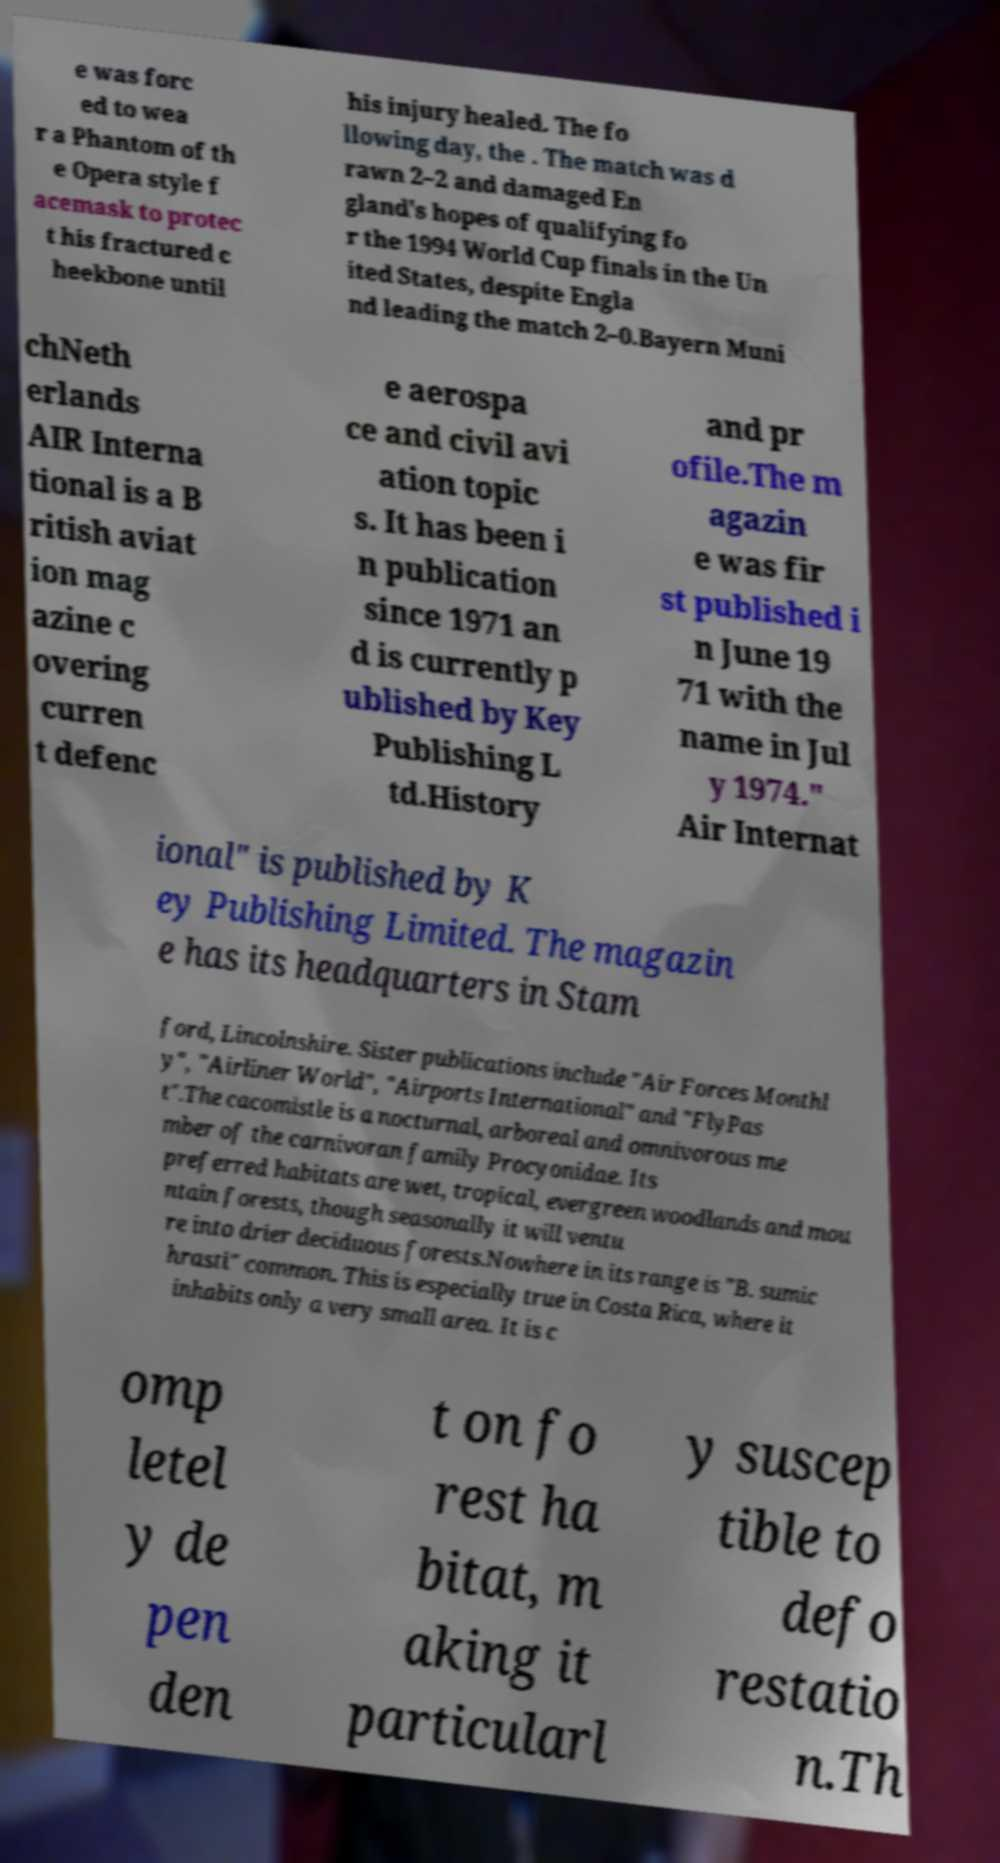For documentation purposes, I need the text within this image transcribed. Could you provide that? e was forc ed to wea r a Phantom of th e Opera style f acemask to protec t his fractured c heekbone until his injury healed. The fo llowing day, the . The match was d rawn 2–2 and damaged En gland's hopes of qualifying fo r the 1994 World Cup finals in the Un ited States, despite Engla nd leading the match 2–0.Bayern Muni chNeth erlands AIR Interna tional is a B ritish aviat ion mag azine c overing curren t defenc e aerospa ce and civil avi ation topic s. It has been i n publication since 1971 an d is currently p ublished by Key Publishing L td.History and pr ofile.The m agazin e was fir st published i n June 19 71 with the name in Jul y 1974." Air Internat ional" is published by K ey Publishing Limited. The magazin e has its headquarters in Stam ford, Lincolnshire. Sister publications include "Air Forces Monthl y", "Airliner World", "Airports International" and "FlyPas t".The cacomistle is a nocturnal, arboreal and omnivorous me mber of the carnivoran family Procyonidae. Its preferred habitats are wet, tropical, evergreen woodlands and mou ntain forests, though seasonally it will ventu re into drier deciduous forests.Nowhere in its range is "B. sumic hrasti" common. This is especially true in Costa Rica, where it inhabits only a very small area. It is c omp letel y de pen den t on fo rest ha bitat, m aking it particularl y suscep tible to defo restatio n.Th 